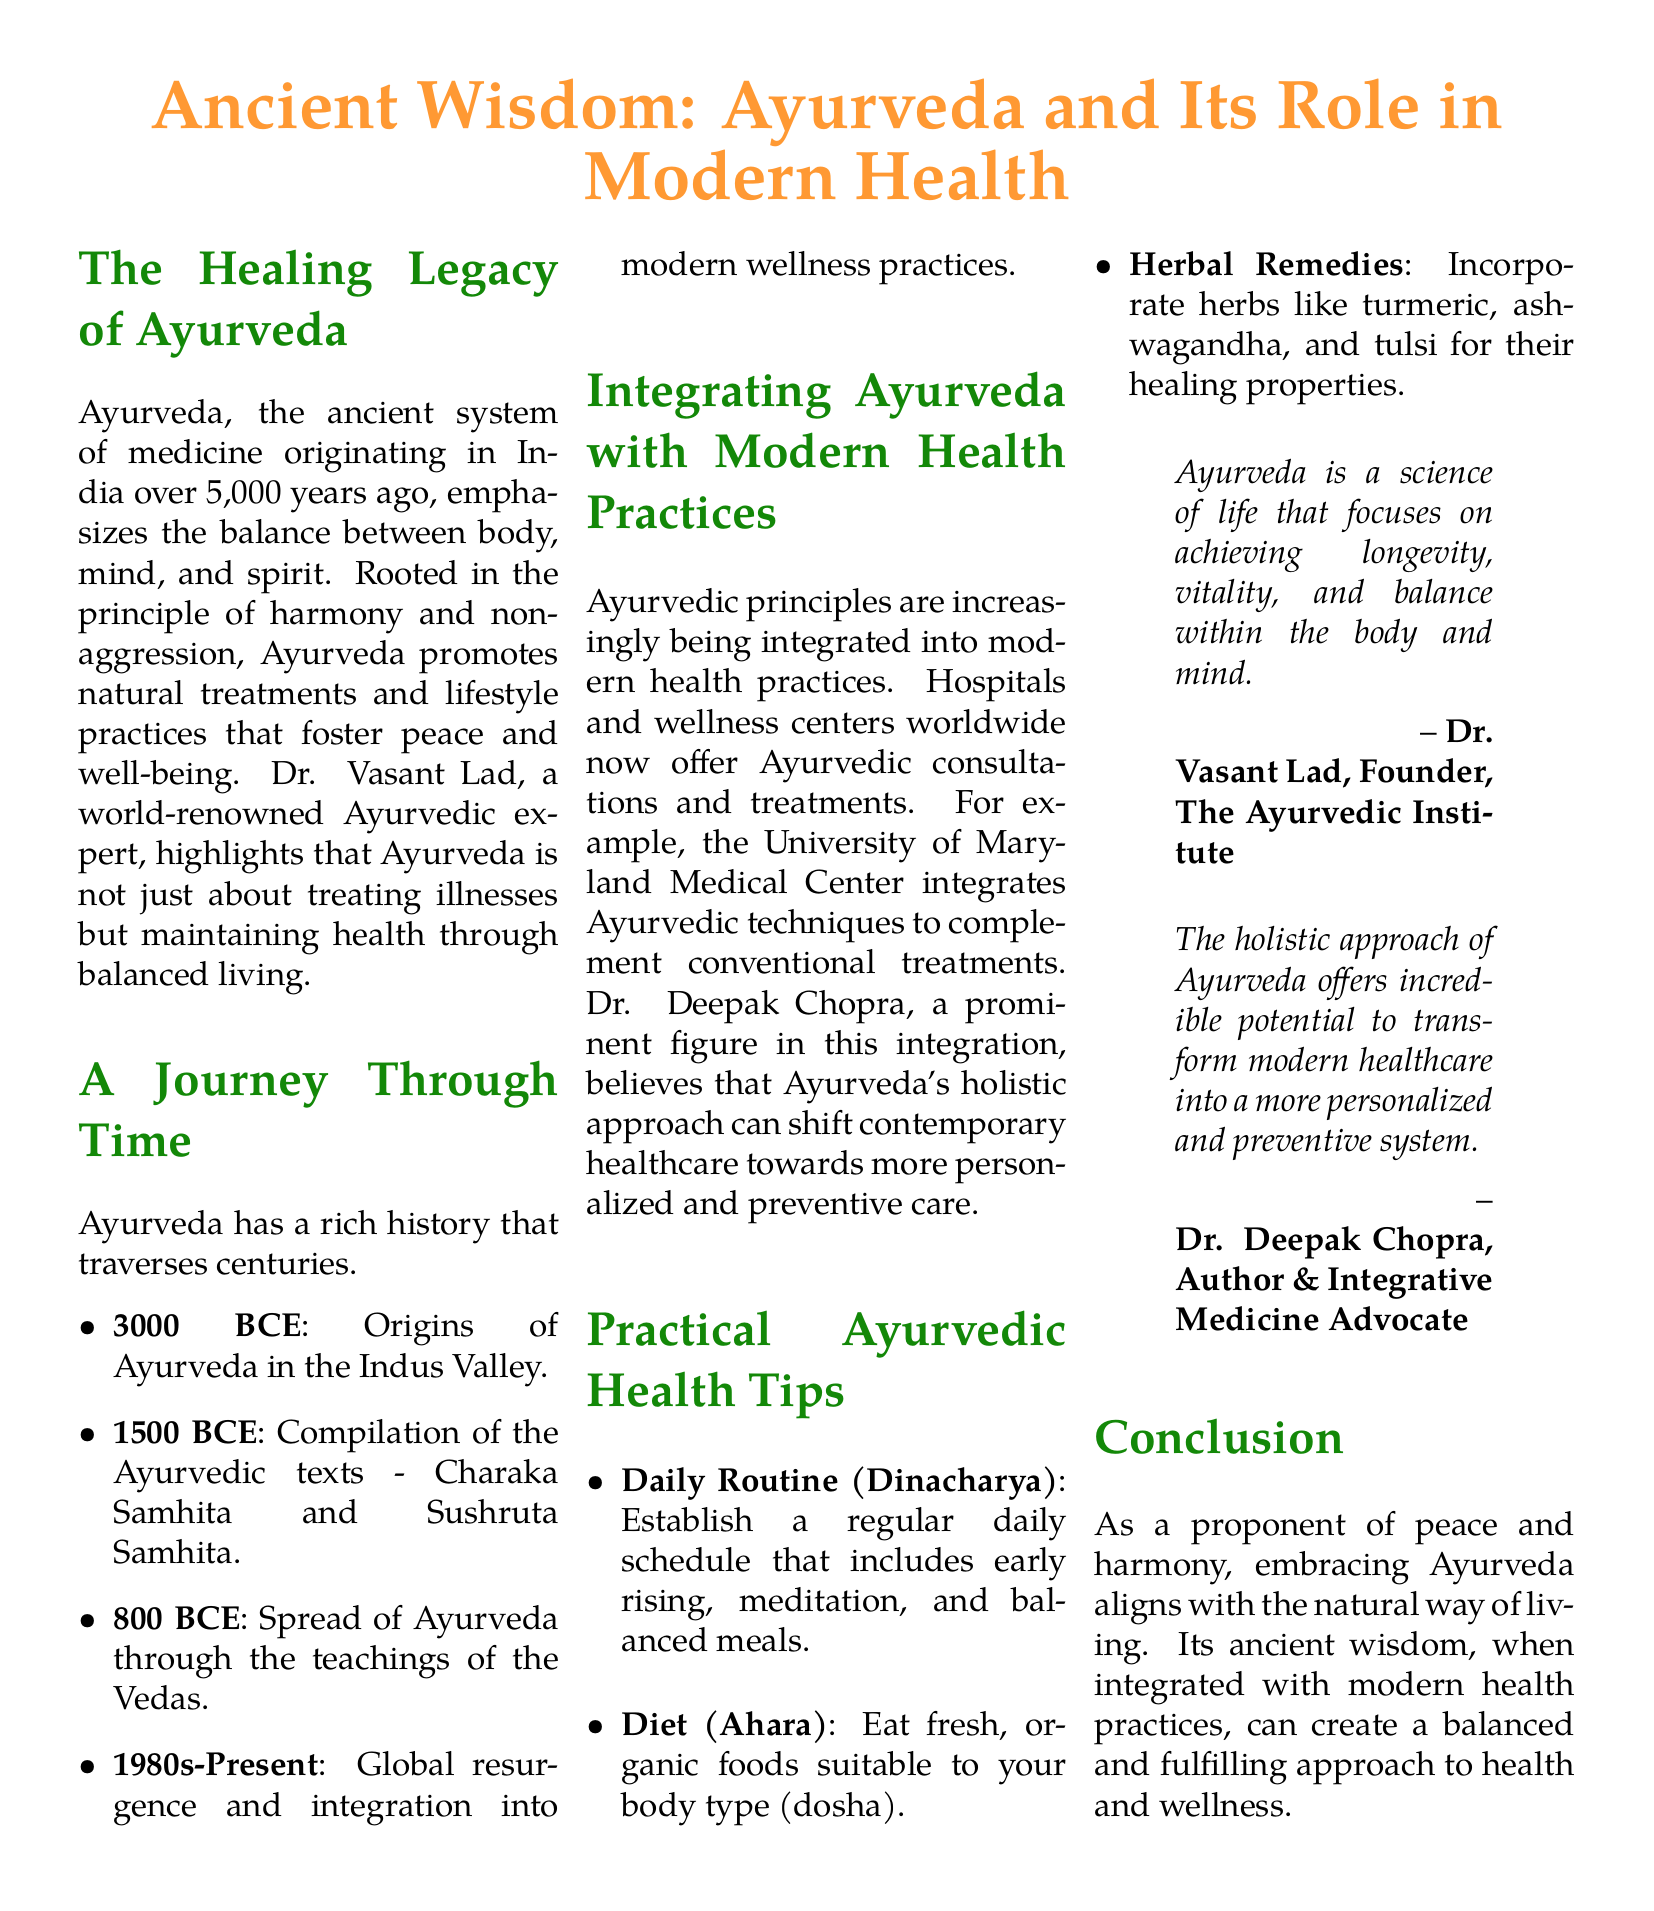What are the origins of Ayurveda? The origins of Ayurveda date back to the Indus Valley around 3000 BCE.
Answer: 3000 BCE Who compiled the Ayurvedic texts? The Ayurvedic texts, Charaka Samhita and Sushruta Samhita, were compiled around 1500 BCE.
Answer: Charaka Samhita and Sushruta Samhita What is Dr. Vasant Lad's profession? Dr. Vasant Lad is a world-renowned Ayurvedic expert and the founder of The Ayurvedic Institute.
Answer: Ayurvedic expert Which herb is mentioned for its healing properties? The document mentions turmeric as a beneficial herb in Ayurveda for healing.
Answer: Turmeric What is the main focus of Ayurveda according to Dr. Vasant Lad? According to Dr. Vasant Lad, Ayurveda focuses on achieving longevity, vitality, and balance.
Answer: Longevity, vitality, and balance When did Ayurveda see a global resurgence? The document states that Ayurveda's global resurgence started in the 1980s and continues to the present.
Answer: 1980s-Present What approach does Dr. Deepak Chopra advocate for in modern healthcare? Dr. Deepak Chopra believes in integrating Ayurveda's holistic approach into modern healthcare.
Answer: Holistic approach What is the importance of a daily routine in Ayurveda? Establishing a daily routine (Dinacharya) is emphasized to promote balance and health.
Answer: Balance and health What does the term 'Ahara' refer to in Ayurveda? 'Ahara' refers to the diet and eating fresh, organic foods suitable for one's body type.
Answer: Diet and organic foods 